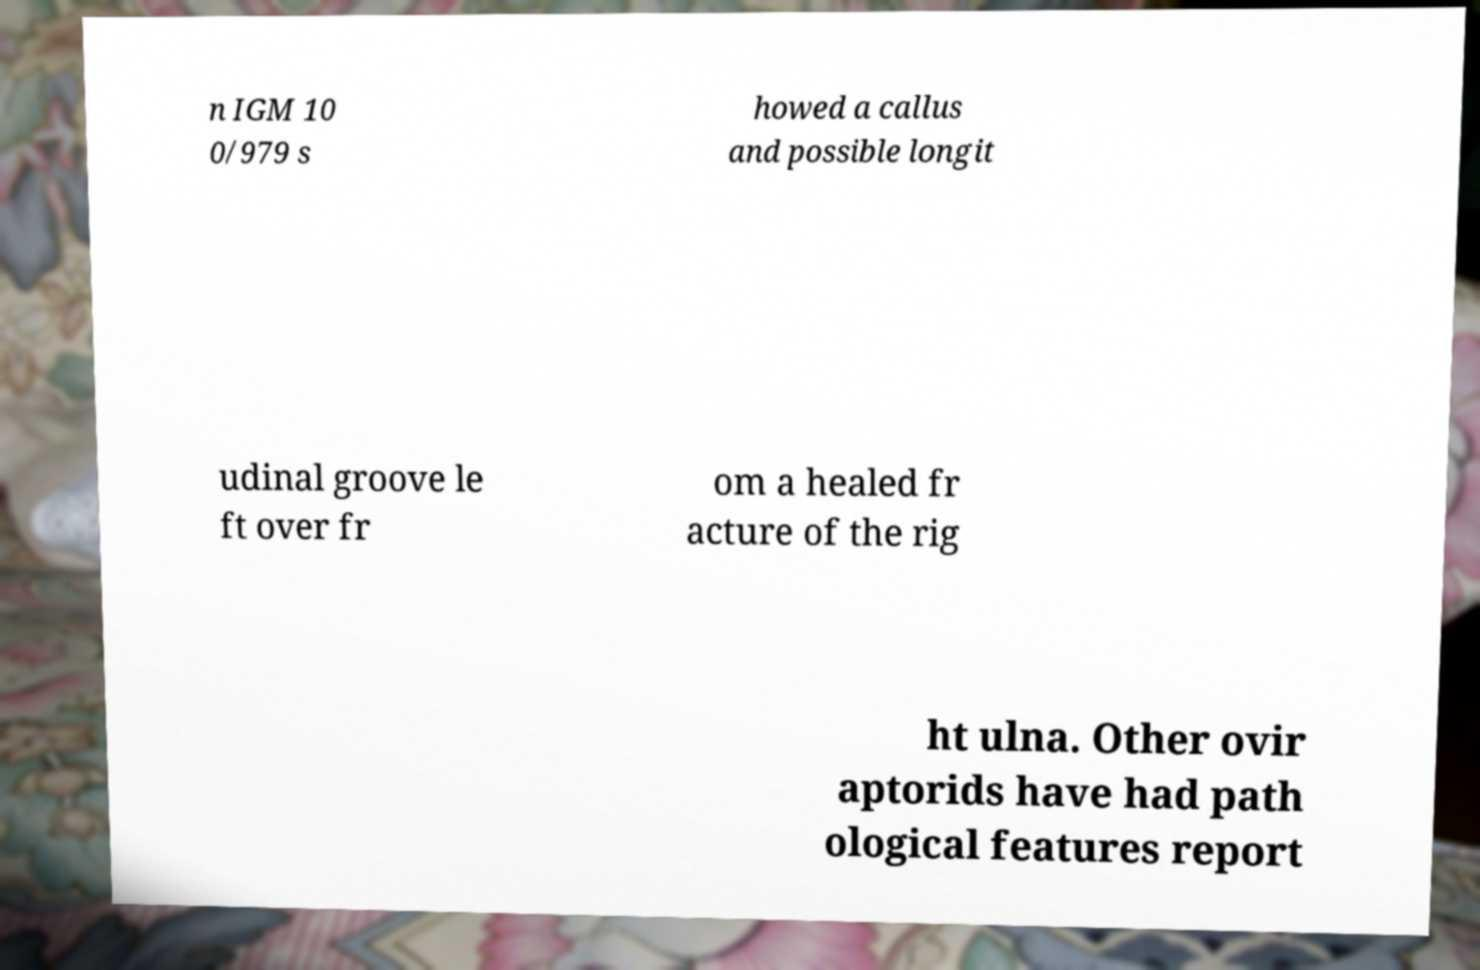Please read and relay the text visible in this image. What does it say? n IGM 10 0/979 s howed a callus and possible longit udinal groove le ft over fr om a healed fr acture of the rig ht ulna. Other ovir aptorids have had path ological features report 